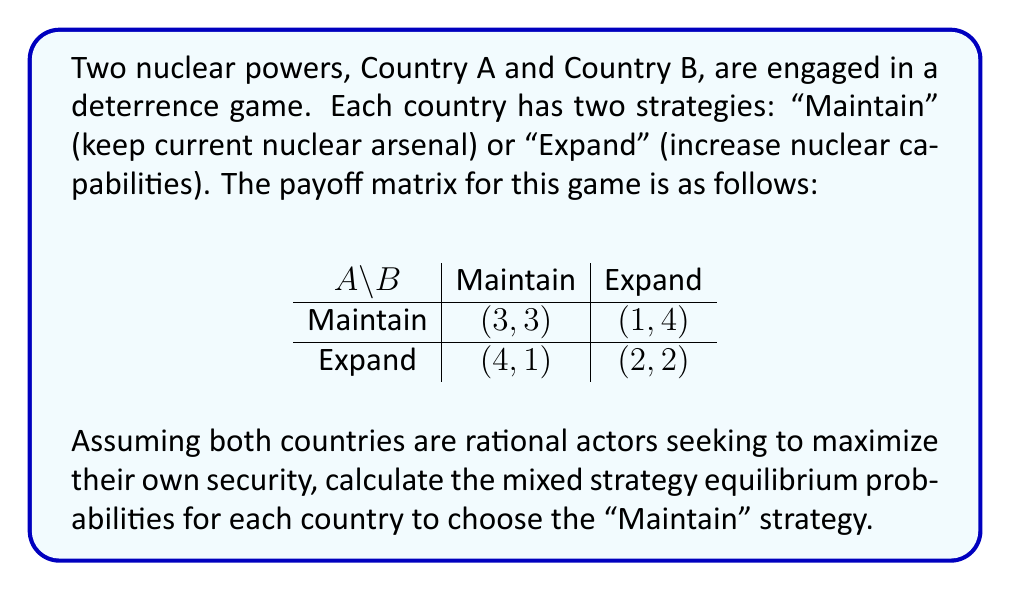Teach me how to tackle this problem. To solve this problem, we'll follow these steps:

1) Let $p$ be the probability that Country A chooses "Maintain", and $q$ be the probability that Country B chooses "Maintain".

2) For a mixed strategy equilibrium, each country must be indifferent between their two strategies. We can express this as two equations:

For Country A:
$$3q + 1(1-q) = 4q + 2(1-q)$$

For Country B:
$$3p + 4(1-p) = p + 2(1-p)$$

3) Simplify the equations:

For Country A:
$$3q + 1 - q = 4q + 2 - 2q$$
$$2q + 1 = 2q + 2$$
$$1 = 1$$

This equation is always true, so it doesn't help us find $q$.

For Country B:
$$3p + 4 - 4p = p + 2 - 2p$$
$$3p - 4p = -2p + 2 - 4$$
$$p = \frac{2}{3}$$

4) To find $q$, we use the fact that in equilibrium, Country A must be indifferent between its strategies. We can set up an equation based on Country A's expected payoffs:

$$3q + 1(1-q) = 4q + 2(1-q)$$
$$3q + 1 - q = 4q + 2 - 2q$$
$$2q + 1 = 2q + 2$$
$$1 = 1$$

This equation is always true, meaning Country A is indifferent between its strategies for any value of $q$ that Country B chooses. In game theory, when this occurs, we typically assume that the other player (in this case, Country B) will choose the probability that makes the first player indifferent between pure strategies.

5) To find this probability, we set Country A's expected payoffs from its pure strategies equal:

$$3q + 1(1-q) = 4q + 2(1-q)$$
$$3q + 1 - q = 4q + 2 - 2q$$
$$2q + 1 = 2q + 2$$
$$1 = 1$$

Again, this is always true. In this case, we can conclude that Country B is also indifferent between its strategies, and can choose any probability $q$.

Therefore, the mixed strategy equilibrium is:
Country A chooses "Maintain" with probability $p = \frac{2}{3}$
Country B can choose any probability $q$ for "Maintain"
Answer: The mixed strategy equilibrium probabilities are:
Country A: $p = \frac{2}{3}$ for "Maintain"
Country B: Any probability $q$ for "Maintain" 